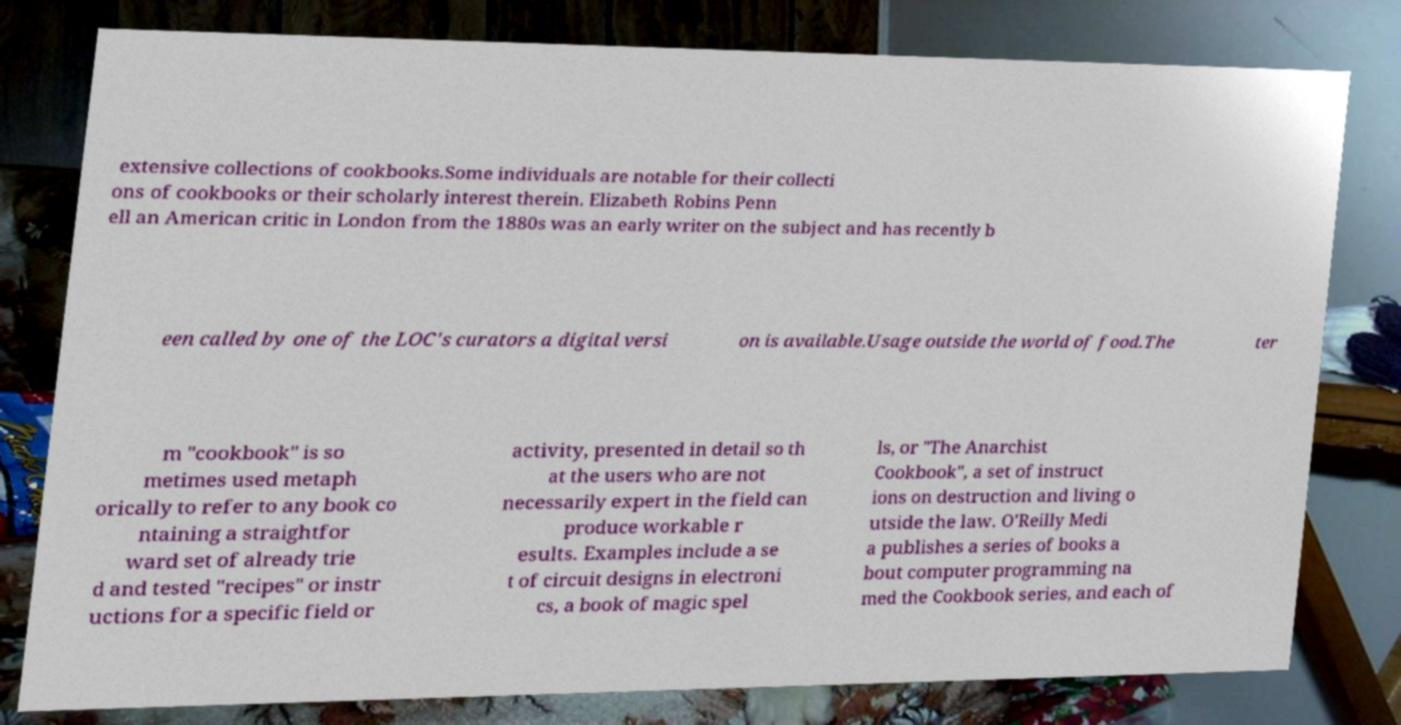Can you accurately transcribe the text from the provided image for me? extensive collections of cookbooks.Some individuals are notable for their collecti ons of cookbooks or their scholarly interest therein. Elizabeth Robins Penn ell an American critic in London from the 1880s was an early writer on the subject and has recently b een called by one of the LOC's curators a digital versi on is available.Usage outside the world of food.The ter m "cookbook" is so metimes used metaph orically to refer to any book co ntaining a straightfor ward set of already trie d and tested "recipes" or instr uctions for a specific field or activity, presented in detail so th at the users who are not necessarily expert in the field can produce workable r esults. Examples include a se t of circuit designs in electroni cs, a book of magic spel ls, or "The Anarchist Cookbook", a set of instruct ions on destruction and living o utside the law. O'Reilly Medi a publishes a series of books a bout computer programming na med the Cookbook series, and each of 